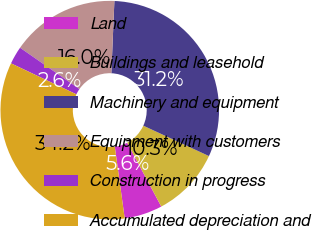Convert chart to OTSL. <chart><loc_0><loc_0><loc_500><loc_500><pie_chart><fcel>Land<fcel>Buildings and leasehold<fcel>Machinery and equipment<fcel>Equipment with customers<fcel>Construction in progress<fcel>Accumulated depreciation and<nl><fcel>5.63%<fcel>10.29%<fcel>31.23%<fcel>16.0%<fcel>2.63%<fcel>34.23%<nl></chart> 